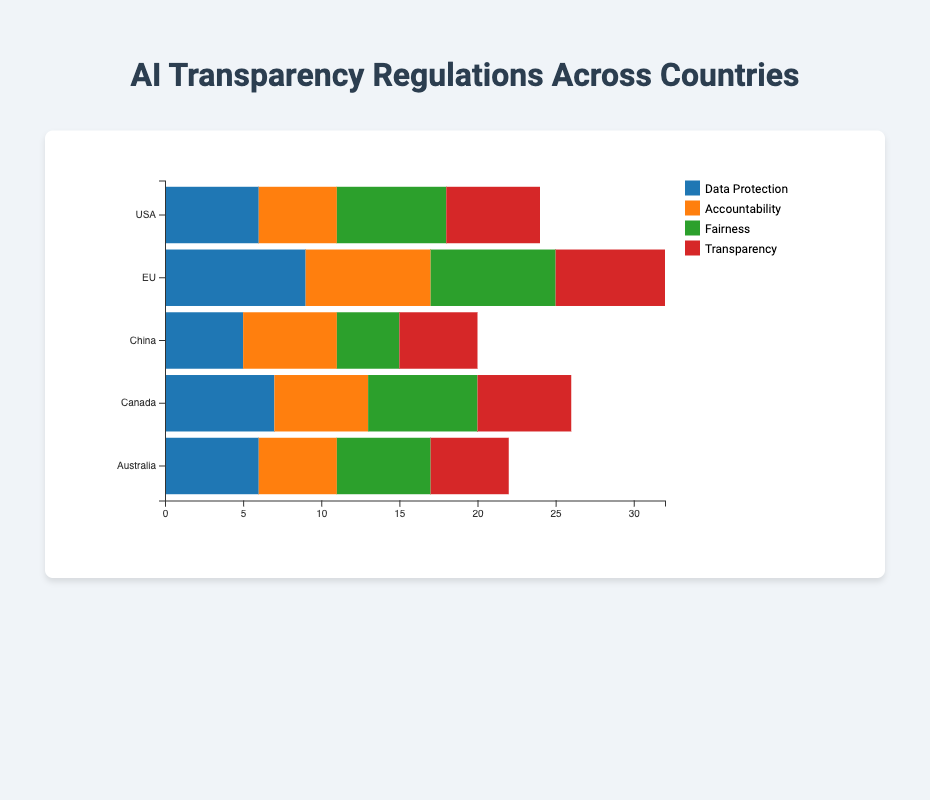Which country has the highest level of Data Protection measures? The country with the highest level of Data Protection measures is identified by looking for the highest value in the Data Protection bar across all countries. The EU has the highest value of 9.
Answer: EU Which type of legislation is least regulated in China? By comparing the lengths of the bars for China's different legislations, Fairness has the smallest value which is 4.
Answer: Fairness How does Canada's level of Transparency compare to Australia's? By comparing the Transparency bars for both countries, Canada's Transparency measures are represented by a length 6, and Australia's by a length of 5. Hence, Canada's level is higher.
Answer: Canada has higher Transparency measures than Australia What is the sum of Accountability and Transparency measures in the USA? In the USA, the Accountability measure is 5 and the Transparency measure is 6. Adding these values, 5 + 6, equals 11.
Answer: 11 Which country has a combined score of Fairness and Transparency closest to 13? To find the country with a combined score closest to 13, we add the Fairness and Transparency measures for each country: 
- USA: 7+6 = 13
- EU: 8+7 = 15 
- China: 4+5 = 9 
- Canada: 7+6 = 13 
- Australia: 6+5 = 11
Both the USA and Canada have a combined score of 13.
Answer: USA and Canada What is the total sum of all regulatory measures (across all legislation types) for the EU? First, sum the values of each legislation type for the EU. Data Protection (9) + Accountability (8) + Fairness (8) + Transparency (7) equals a total of 32.
Answer: 32 Which legislation type has the highest average measure across all countries? Summing up the measures for each legislation type across all countries and dividing by the number of countries (5):
- Data Protection: (6+9+5+7+6) / 5 = 6.6
- Accountability: (5+8+6+6+5) / 5 = 6
- Fairness: (7+8+4+7+6) / 5 = 6.4
- Transparency: (6+7+5+6+5) / 5 = 5.8
Data Protection has the highest average measure of 6.6.
Answer: Data Protection What's the total length of the Fairness measures' stacked bar sections across all countries? Adding the values for the Fairness measures from all countries: 7 (USA) + 8 (EU) + 4 (China) + 7 (Canada) + 6 (Australia) equals 32.
Answer: 32 Which country's bar has the longest total length when combining all four types of legislation? By adding the values for all four types for each country: 
- USA: 6+5+7+6 = 24
- EU: 9+8+8+7 = 32 
- China: 5+6+4+5 = 20 
- Canada: 7+6+7+6 = 26 
- Australia: 6+5+6+5 = 22
The EU has the longest total bar length at 32.
Answer: EU 